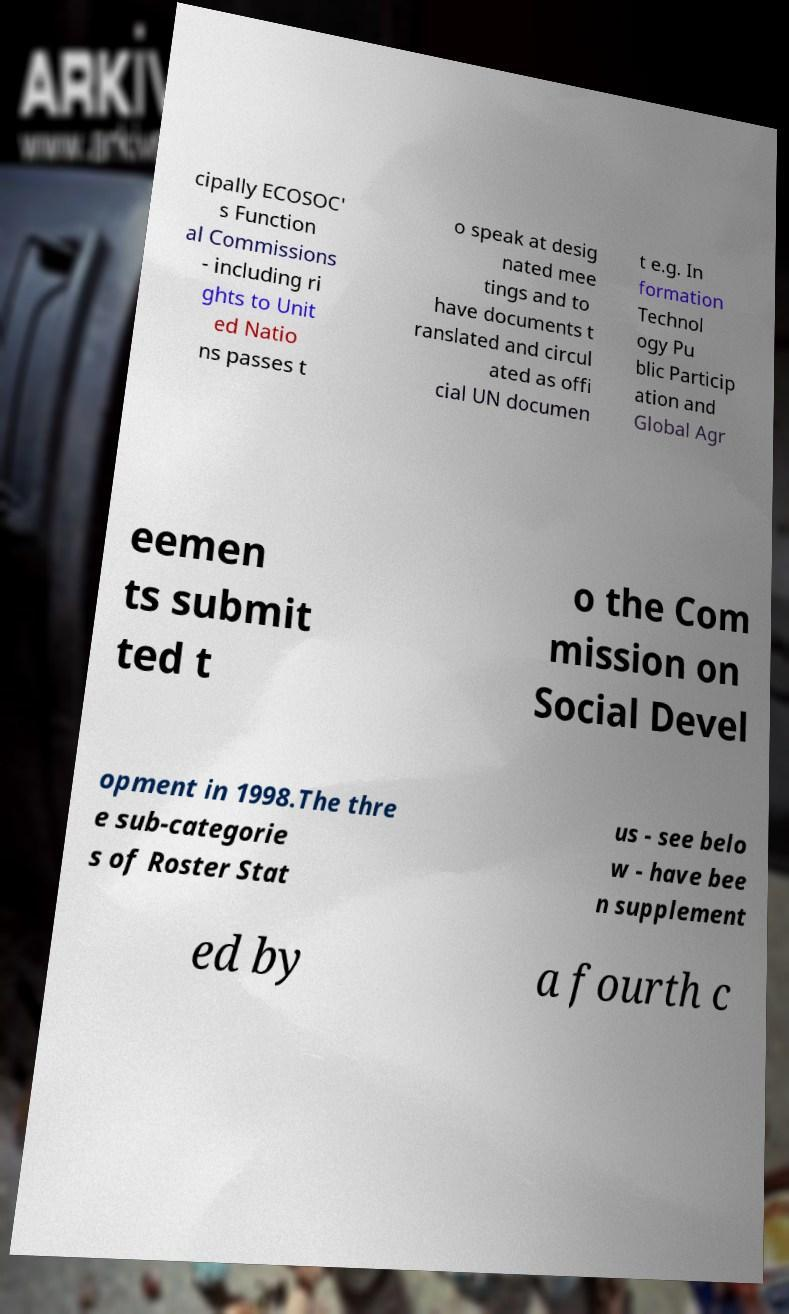Could you assist in decoding the text presented in this image and type it out clearly? cipally ECOSOC' s Function al Commissions - including ri ghts to Unit ed Natio ns passes t o speak at desig nated mee tings and to have documents t ranslated and circul ated as offi cial UN documen t e.g. In formation Technol ogy Pu blic Particip ation and Global Agr eemen ts submit ted t o the Com mission on Social Devel opment in 1998.The thre e sub-categorie s of Roster Stat us - see belo w - have bee n supplement ed by a fourth c 